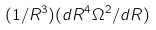<formula> <loc_0><loc_0><loc_500><loc_500>( 1 / R ^ { 3 } ) ( d R ^ { 4 } \Omega ^ { 2 } / d R )</formula> 